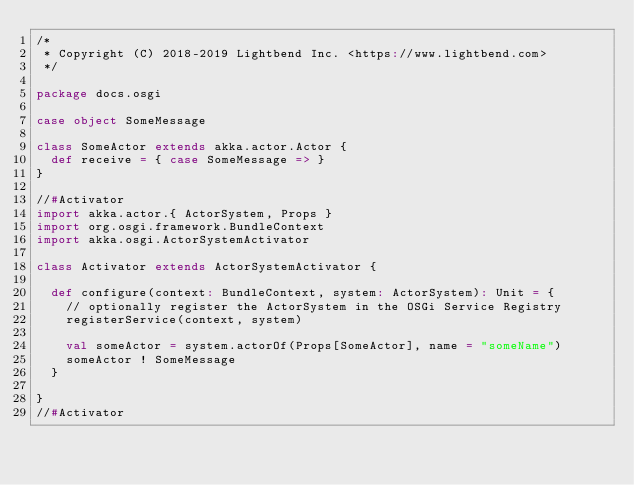<code> <loc_0><loc_0><loc_500><loc_500><_Scala_>/*
 * Copyright (C) 2018-2019 Lightbend Inc. <https://www.lightbend.com>
 */

package docs.osgi

case object SomeMessage

class SomeActor extends akka.actor.Actor {
  def receive = { case SomeMessage => }
}

//#Activator
import akka.actor.{ ActorSystem, Props }
import org.osgi.framework.BundleContext
import akka.osgi.ActorSystemActivator

class Activator extends ActorSystemActivator {

  def configure(context: BundleContext, system: ActorSystem): Unit = {
    // optionally register the ActorSystem in the OSGi Service Registry
    registerService(context, system)

    val someActor = system.actorOf(Props[SomeActor], name = "someName")
    someActor ! SomeMessage
  }

}
//#Activator
</code> 